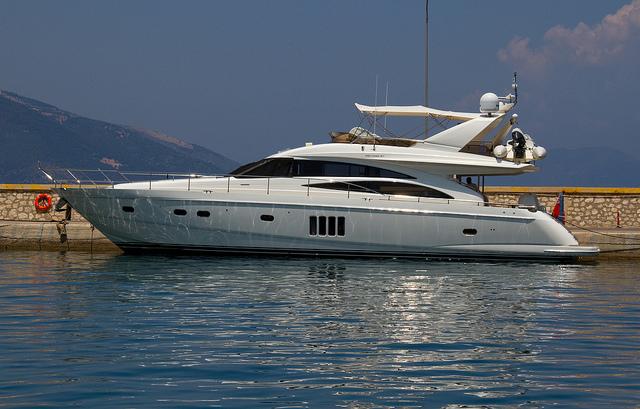What kind of boat is this?
Concise answer only. Yacht. What mountain is in the background?
Be succinct. Everest. What color is the photo?
Be succinct. Blue. What harbor is the boat in?
Short answer required. Pearl. 